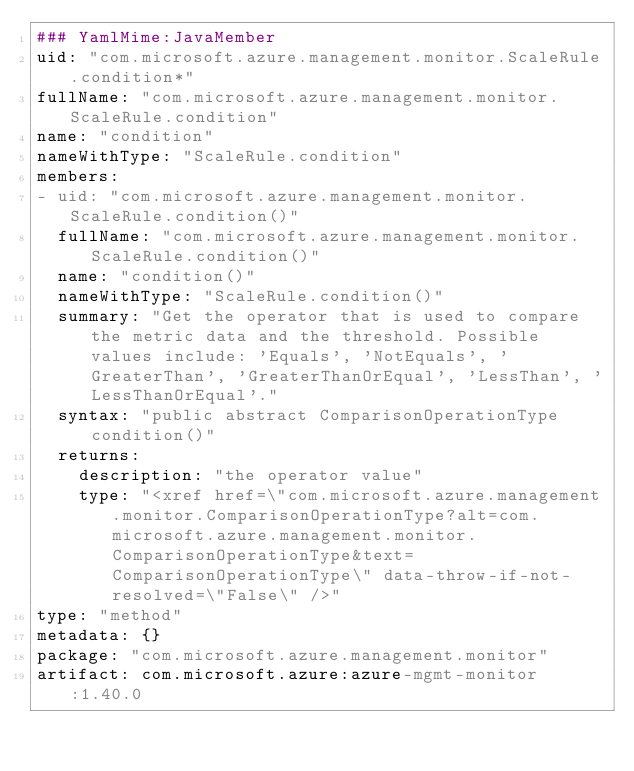<code> <loc_0><loc_0><loc_500><loc_500><_YAML_>### YamlMime:JavaMember
uid: "com.microsoft.azure.management.monitor.ScaleRule.condition*"
fullName: "com.microsoft.azure.management.monitor.ScaleRule.condition"
name: "condition"
nameWithType: "ScaleRule.condition"
members:
- uid: "com.microsoft.azure.management.monitor.ScaleRule.condition()"
  fullName: "com.microsoft.azure.management.monitor.ScaleRule.condition()"
  name: "condition()"
  nameWithType: "ScaleRule.condition()"
  summary: "Get the operator that is used to compare the metric data and the threshold. Possible values include: 'Equals', 'NotEquals', 'GreaterThan', 'GreaterThanOrEqual', 'LessThan', 'LessThanOrEqual'."
  syntax: "public abstract ComparisonOperationType condition()"
  returns:
    description: "the operator value"
    type: "<xref href=\"com.microsoft.azure.management.monitor.ComparisonOperationType?alt=com.microsoft.azure.management.monitor.ComparisonOperationType&text=ComparisonOperationType\" data-throw-if-not-resolved=\"False\" />"
type: "method"
metadata: {}
package: "com.microsoft.azure.management.monitor"
artifact: com.microsoft.azure:azure-mgmt-monitor:1.40.0
</code> 